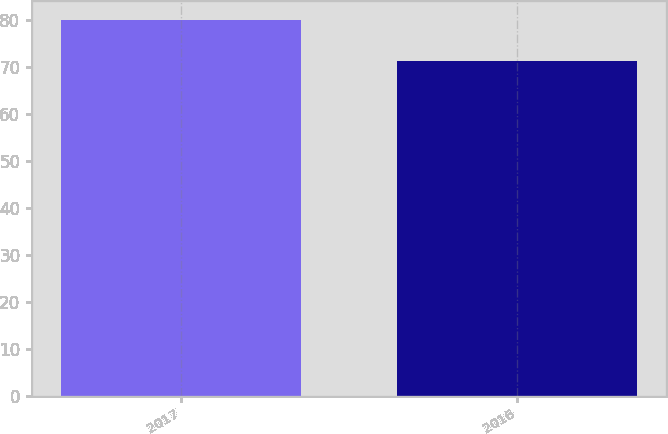<chart> <loc_0><loc_0><loc_500><loc_500><bar_chart><fcel>2017<fcel>2016<nl><fcel>80.02<fcel>71.23<nl></chart> 